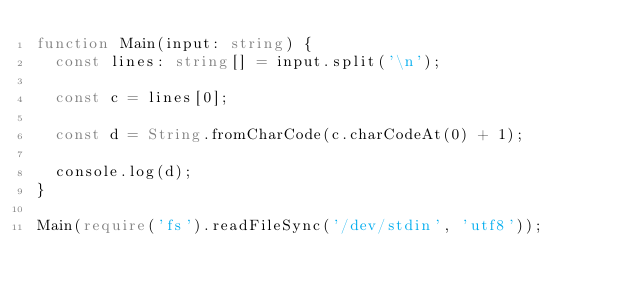<code> <loc_0><loc_0><loc_500><loc_500><_TypeScript_>function Main(input: string) {
  const lines: string[] = input.split('\n');

  const c = lines[0];

  const d = String.fromCharCode(c.charCodeAt(0) + 1);

  console.log(d);
}

Main(require('fs').readFileSync('/dev/stdin', 'utf8'));</code> 